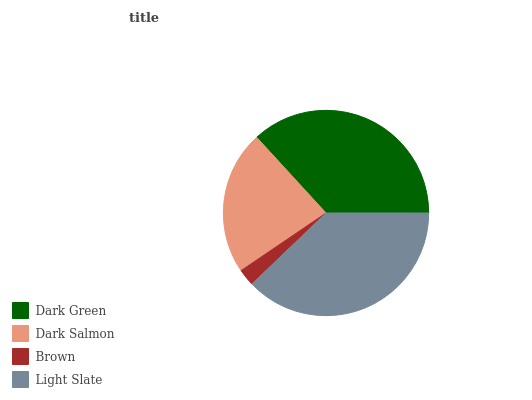Is Brown the minimum?
Answer yes or no. Yes. Is Light Slate the maximum?
Answer yes or no. Yes. Is Dark Salmon the minimum?
Answer yes or no. No. Is Dark Salmon the maximum?
Answer yes or no. No. Is Dark Green greater than Dark Salmon?
Answer yes or no. Yes. Is Dark Salmon less than Dark Green?
Answer yes or no. Yes. Is Dark Salmon greater than Dark Green?
Answer yes or no. No. Is Dark Green less than Dark Salmon?
Answer yes or no. No. Is Dark Green the high median?
Answer yes or no. Yes. Is Dark Salmon the low median?
Answer yes or no. Yes. Is Light Slate the high median?
Answer yes or no. No. Is Dark Green the low median?
Answer yes or no. No. 